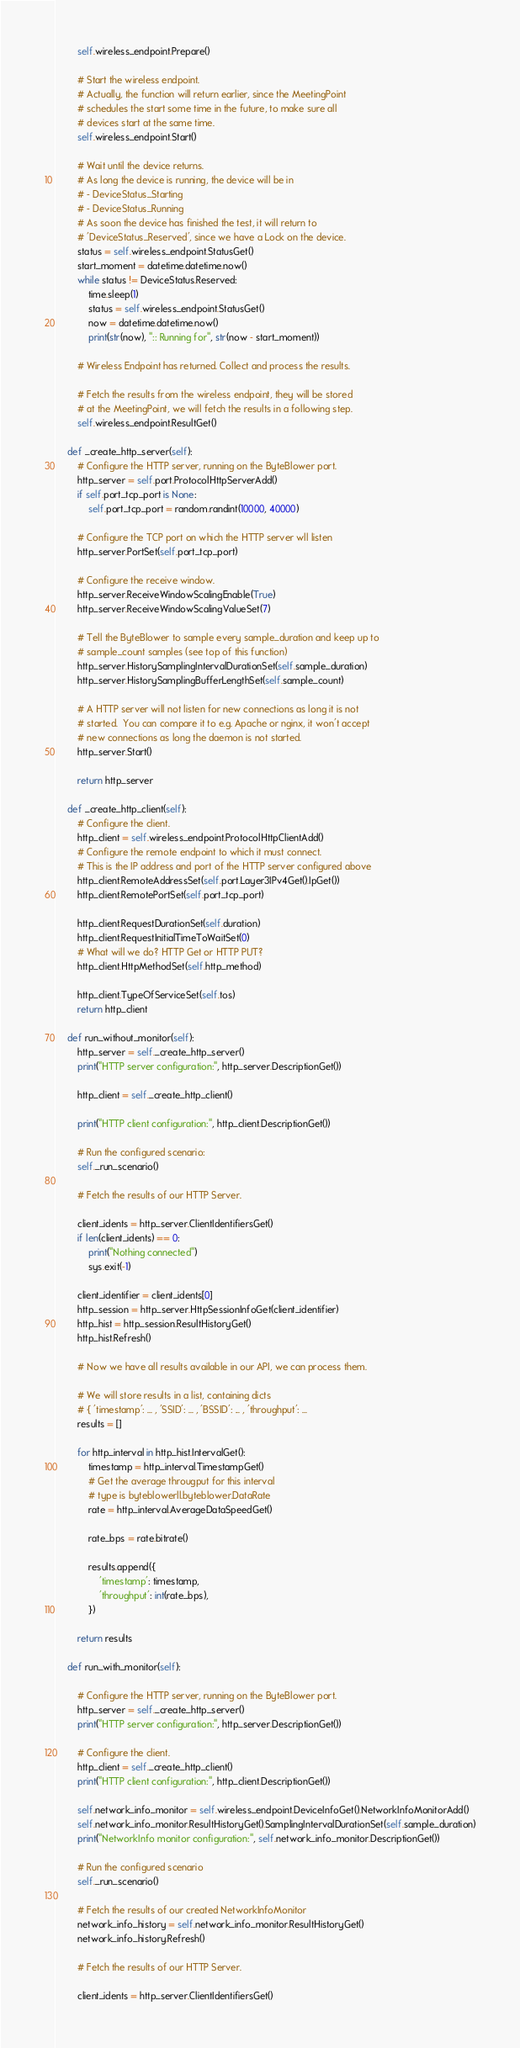<code> <loc_0><loc_0><loc_500><loc_500><_Python_>        self.wireless_endpoint.Prepare()

        # Start the wireless endpoint.
        # Actually, the function will return earlier, since the MeetingPoint
        # schedules the start some time in the future, to make sure all
        # devices start at the same time.
        self.wireless_endpoint.Start()

        # Wait until the device returns.
        # As long the device is running, the device will be in
        # - DeviceStatus_Starting
        # - DeviceStatus_Running
        # As soon the device has finished the test, it will return to
        # 'DeviceStatus_Reserved', since we have a Lock on the device.
        status = self.wireless_endpoint.StatusGet()
        start_moment = datetime.datetime.now()
        while status != DeviceStatus.Reserved:
            time.sleep(1)
            status = self.wireless_endpoint.StatusGet()
            now = datetime.datetime.now()
            print(str(now), ":: Running for", str(now - start_moment))

        # Wireless Endpoint has returned. Collect and process the results.

        # Fetch the results from the wireless endpoint, they will be stored
        # at the MeetingPoint, we will fetch the results in a following step.
        self.wireless_endpoint.ResultGet()

    def _create_http_server(self):
        # Configure the HTTP server, running on the ByteBlower port.
        http_server = self.port.ProtocolHttpServerAdd()
        if self.port_tcp_port is None:
            self.port_tcp_port = random.randint(10000, 40000)

        # Configure the TCP port on which the HTTP server wll listen
        http_server.PortSet(self.port_tcp_port)

        # Configure the receive window.
        http_server.ReceiveWindowScalingEnable(True)
        http_server.ReceiveWindowScalingValueSet(7)

        # Tell the ByteBlower to sample every sample_duration and keep up to
        # sample_count samples (see top of this function)
        http_server.HistorySamplingIntervalDurationSet(self.sample_duration)
        http_server.HistorySamplingBufferLengthSet(self.sample_count)

        # A HTTP server will not listen for new connections as long it is not
        # started.  You can compare it to e.g. Apache or nginx, it won't accept
        # new connections as long the daemon is not started.
        http_server.Start()

        return http_server

    def _create_http_client(self):
        # Configure the client.
        http_client = self.wireless_endpoint.ProtocolHttpClientAdd()
        # Configure the remote endpoint to which it must connect.
        # This is the IP address and port of the HTTP server configured above
        http_client.RemoteAddressSet(self.port.Layer3IPv4Get().IpGet())
        http_client.RemotePortSet(self.port_tcp_port)

        http_client.RequestDurationSet(self.duration)
        http_client.RequestInitialTimeToWaitSet(0)
        # What will we do? HTTP Get or HTTP PUT?
        http_client.HttpMethodSet(self.http_method)

        http_client.TypeOfServiceSet(self.tos)
        return http_client

    def run_without_monitor(self):
        http_server = self._create_http_server()
        print("HTTP server configuration:", http_server.DescriptionGet())

        http_client = self._create_http_client()

        print("HTTP client configuration:", http_client.DescriptionGet())

        # Run the configured scenario:
        self._run_scenario()

        # Fetch the results of our HTTP Server.

        client_idents = http_server.ClientIdentifiersGet()
        if len(client_idents) == 0:
            print("Nothing connected")
            sys.exit(-1)

        client_identifier = client_idents[0]
        http_session = http_server.HttpSessionInfoGet(client_identifier)
        http_hist = http_session.ResultHistoryGet()
        http_hist.Refresh()

        # Now we have all results available in our API, we can process them.

        # We will store results in a list, containing dicts
        # { 'timestamp': ... , 'SSID': ... , 'BSSID': ... , 'throughput': ...
        results = []

        for http_interval in http_hist.IntervalGet():
            timestamp = http_interval.TimestampGet()
            # Get the average througput for this interval
            # type is byteblowerll.byteblower.DataRate
            rate = http_interval.AverageDataSpeedGet()

            rate_bps = rate.bitrate()

            results.append({
                'timestamp': timestamp,
                'throughput': int(rate_bps),
            })

        return results

    def run_with_monitor(self):

        # Configure the HTTP server, running on the ByteBlower port.
        http_server = self._create_http_server()
        print("HTTP server configuration:", http_server.DescriptionGet())

        # Configure the client.
        http_client = self._create_http_client()
        print("HTTP client configuration:", http_client.DescriptionGet())

        self.network_info_monitor = self.wireless_endpoint.DeviceInfoGet().NetworkInfoMonitorAdd()
        self.network_info_monitor.ResultHistoryGet().SamplingIntervalDurationSet(self.sample_duration)
        print("NetworkInfo monitor configuration:", self.network_info_monitor.DescriptionGet())

        # Run the configured scenario
        self._run_scenario()

        # Fetch the results of our created NetworkInfoMonitor
        network_info_history = self.network_info_monitor.ResultHistoryGet()
        network_info_history.Refresh()

        # Fetch the results of our HTTP Server.

        client_idents = http_server.ClientIdentifiersGet()</code> 